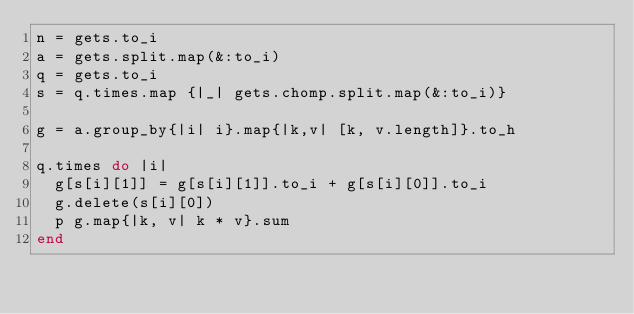Convert code to text. <code><loc_0><loc_0><loc_500><loc_500><_Ruby_>n = gets.to_i
a = gets.split.map(&:to_i)
q = gets.to_i
s = q.times.map {|_| gets.chomp.split.map(&:to_i)}

g = a.group_by{|i| i}.map{|k,v| [k, v.length]}.to_h

q.times do |i|
  g[s[i][1]] = g[s[i][1]].to_i + g[s[i][0]].to_i
  g.delete(s[i][0])
  p g.map{|k, v| k * v}.sum
end</code> 